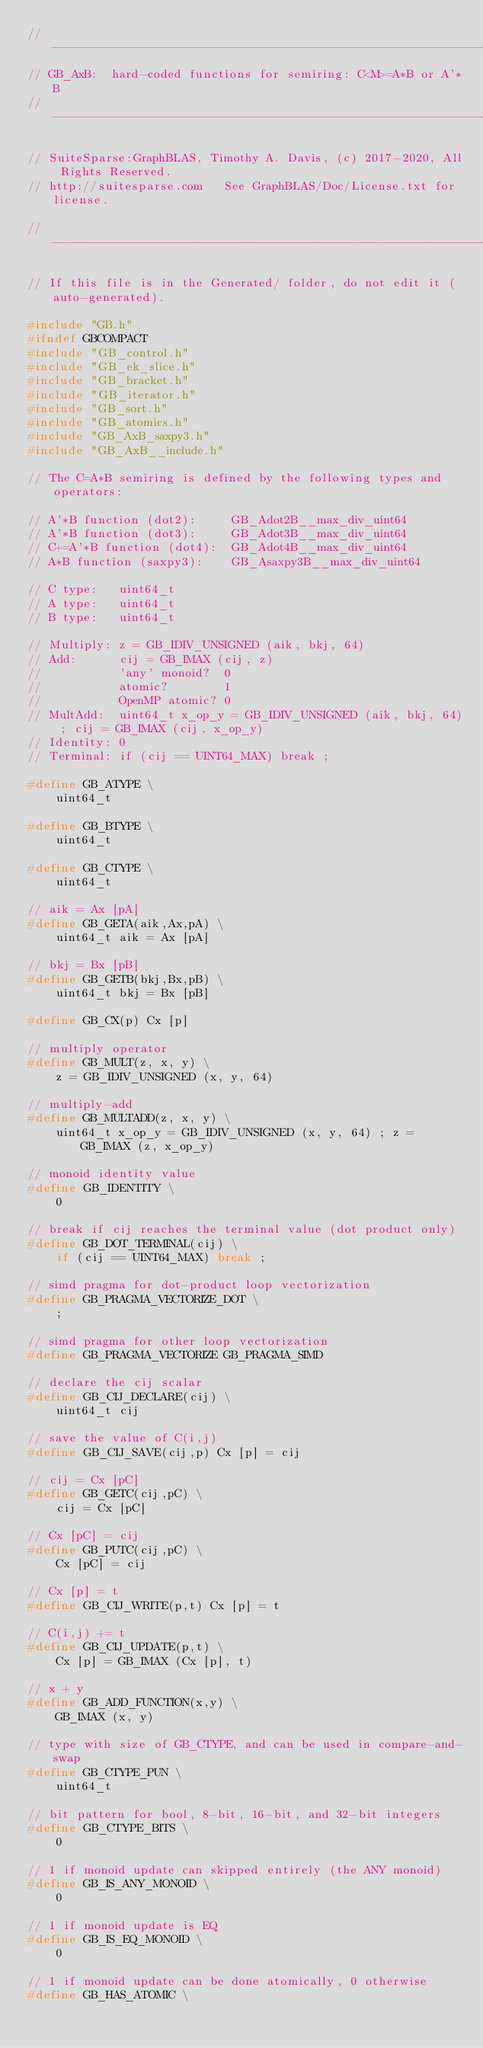Convert code to text. <code><loc_0><loc_0><loc_500><loc_500><_C_>//------------------------------------------------------------------------------
// GB_AxB:  hard-coded functions for semiring: C<M>=A*B or A'*B
//------------------------------------------------------------------------------

// SuiteSparse:GraphBLAS, Timothy A. Davis, (c) 2017-2020, All Rights Reserved.
// http://suitesparse.com   See GraphBLAS/Doc/License.txt for license.

//------------------------------------------------------------------------------

// If this file is in the Generated/ folder, do not edit it (auto-generated).

#include "GB.h"
#ifndef GBCOMPACT
#include "GB_control.h"
#include "GB_ek_slice.h"
#include "GB_bracket.h"
#include "GB_iterator.h"
#include "GB_sort.h"
#include "GB_atomics.h"
#include "GB_AxB_saxpy3.h"
#include "GB_AxB__include.h"

// The C=A*B semiring is defined by the following types and operators:

// A'*B function (dot2):     GB_Adot2B__max_div_uint64
// A'*B function (dot3):     GB_Adot3B__max_div_uint64
// C+=A'*B function (dot4):  GB_Adot4B__max_div_uint64
// A*B function (saxpy3):    GB_Asaxpy3B__max_div_uint64

// C type:   uint64_t
// A type:   uint64_t
// B type:   uint64_t

// Multiply: z = GB_IDIV_UNSIGNED (aik, bkj, 64)
// Add:      cij = GB_IMAX (cij, z)
//           'any' monoid?  0
//           atomic?        1
//           OpenMP atomic? 0
// MultAdd:  uint64_t x_op_y = GB_IDIV_UNSIGNED (aik, bkj, 64) ; cij = GB_IMAX (cij, x_op_y)
// Identity: 0
// Terminal: if (cij == UINT64_MAX) break ;

#define GB_ATYPE \
    uint64_t

#define GB_BTYPE \
    uint64_t

#define GB_CTYPE \
    uint64_t

// aik = Ax [pA]
#define GB_GETA(aik,Ax,pA) \
    uint64_t aik = Ax [pA]

// bkj = Bx [pB]
#define GB_GETB(bkj,Bx,pB) \
    uint64_t bkj = Bx [pB]

#define GB_CX(p) Cx [p]

// multiply operator
#define GB_MULT(z, x, y) \
    z = GB_IDIV_UNSIGNED (x, y, 64)

// multiply-add
#define GB_MULTADD(z, x, y) \
    uint64_t x_op_y = GB_IDIV_UNSIGNED (x, y, 64) ; z = GB_IMAX (z, x_op_y)

// monoid identity value
#define GB_IDENTITY \
    0

// break if cij reaches the terminal value (dot product only)
#define GB_DOT_TERMINAL(cij) \
    if (cij == UINT64_MAX) break ;

// simd pragma for dot-product loop vectorization
#define GB_PRAGMA_VECTORIZE_DOT \
    ;

// simd pragma for other loop vectorization
#define GB_PRAGMA_VECTORIZE GB_PRAGMA_SIMD

// declare the cij scalar
#define GB_CIJ_DECLARE(cij) \
    uint64_t cij

// save the value of C(i,j)
#define GB_CIJ_SAVE(cij,p) Cx [p] = cij

// cij = Cx [pC]
#define GB_GETC(cij,pC) \
    cij = Cx [pC]

// Cx [pC] = cij
#define GB_PUTC(cij,pC) \
    Cx [pC] = cij

// Cx [p] = t
#define GB_CIJ_WRITE(p,t) Cx [p] = t

// C(i,j) += t
#define GB_CIJ_UPDATE(p,t) \
    Cx [p] = GB_IMAX (Cx [p], t)

// x + y
#define GB_ADD_FUNCTION(x,y) \
    GB_IMAX (x, y)

// type with size of GB_CTYPE, and can be used in compare-and-swap
#define GB_CTYPE_PUN \
    uint64_t

// bit pattern for bool, 8-bit, 16-bit, and 32-bit integers
#define GB_CTYPE_BITS \
    0

// 1 if monoid update can skipped entirely (the ANY monoid)
#define GB_IS_ANY_MONOID \
    0

// 1 if monoid update is EQ
#define GB_IS_EQ_MONOID \
    0

// 1 if monoid update can be done atomically, 0 otherwise
#define GB_HAS_ATOMIC \</code> 